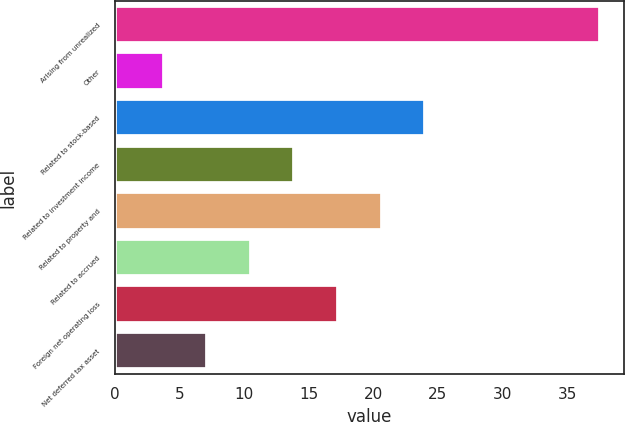Convert chart. <chart><loc_0><loc_0><loc_500><loc_500><bar_chart><fcel>Arising from unrealized<fcel>Other<fcel>Related to stock-based<fcel>Related to investment income<fcel>Related to property and<fcel>Related to accrued<fcel>Foreign net operating loss<fcel>Net deferred tax asset<nl><fcel>37.5<fcel>3.8<fcel>24.02<fcel>13.91<fcel>20.65<fcel>10.54<fcel>17.28<fcel>7.17<nl></chart> 